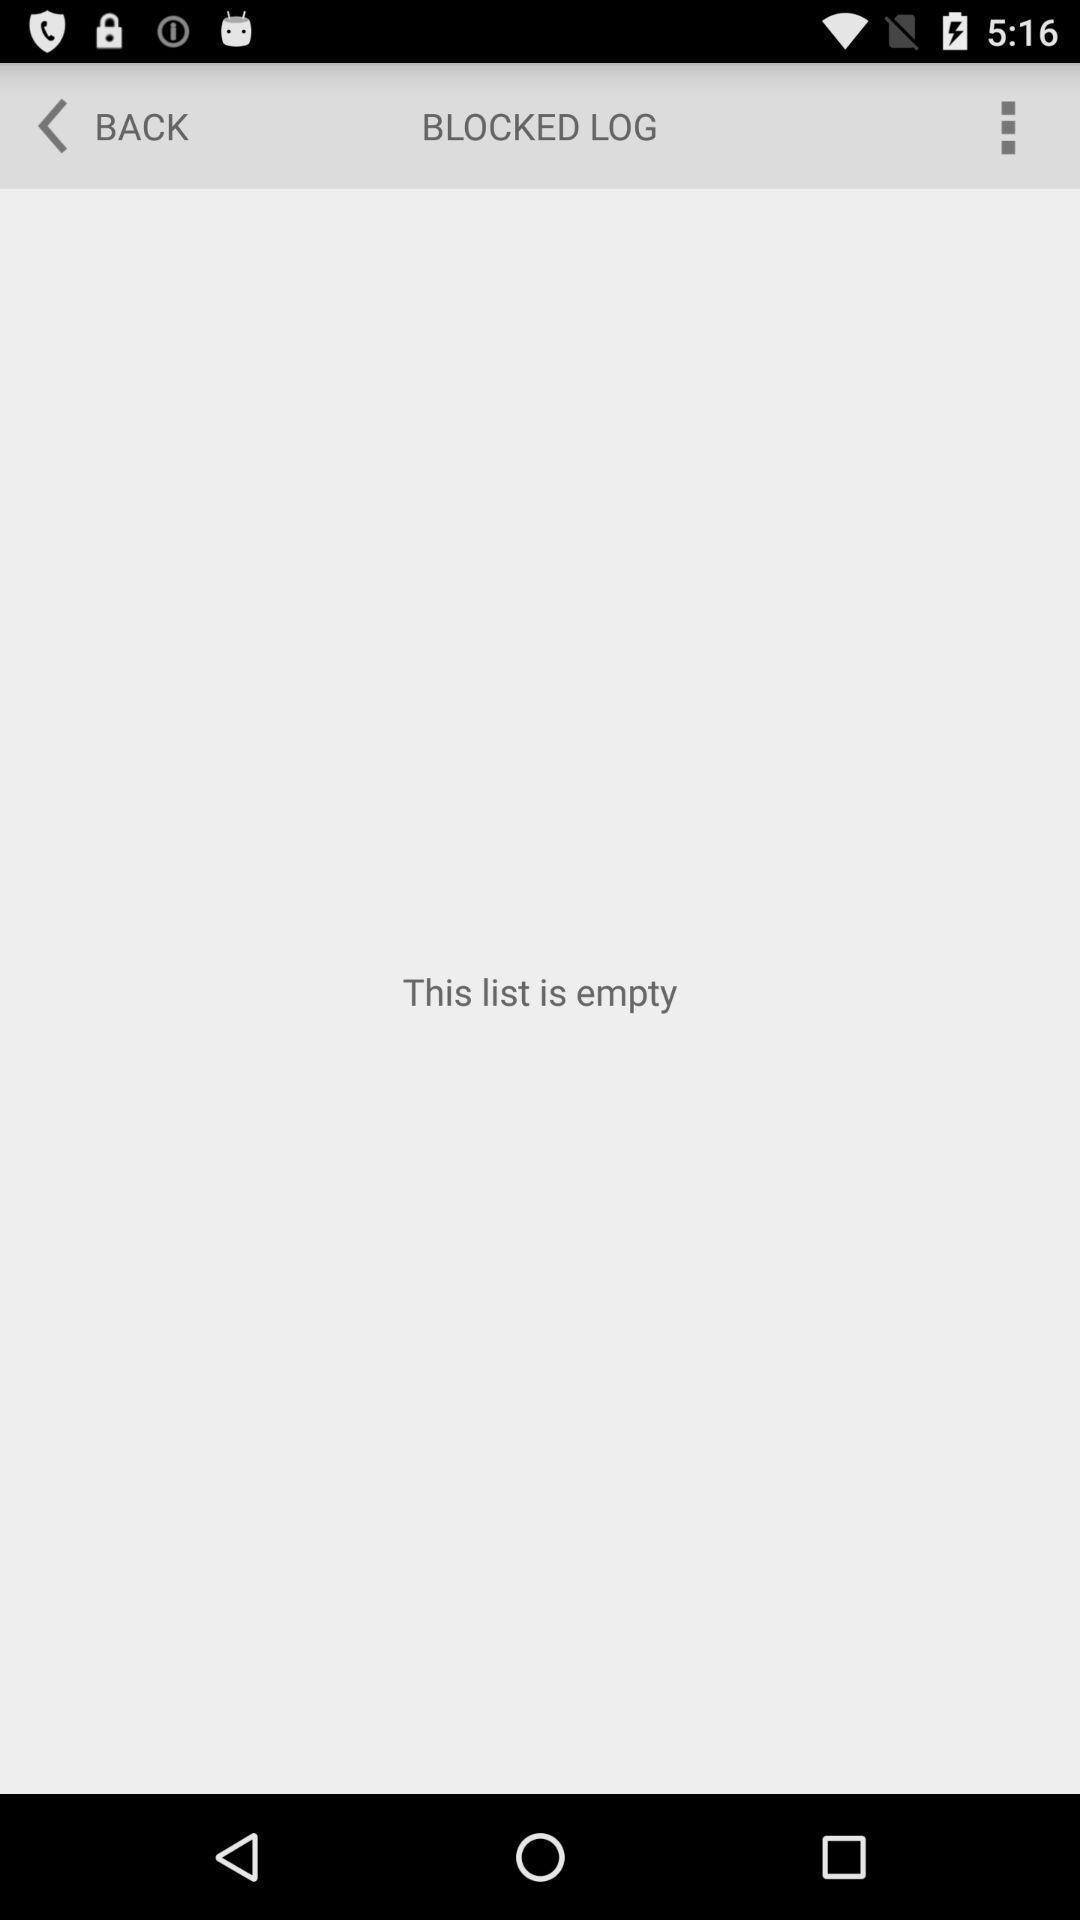Describe the content in this image. Screen displaying the list is empty. 